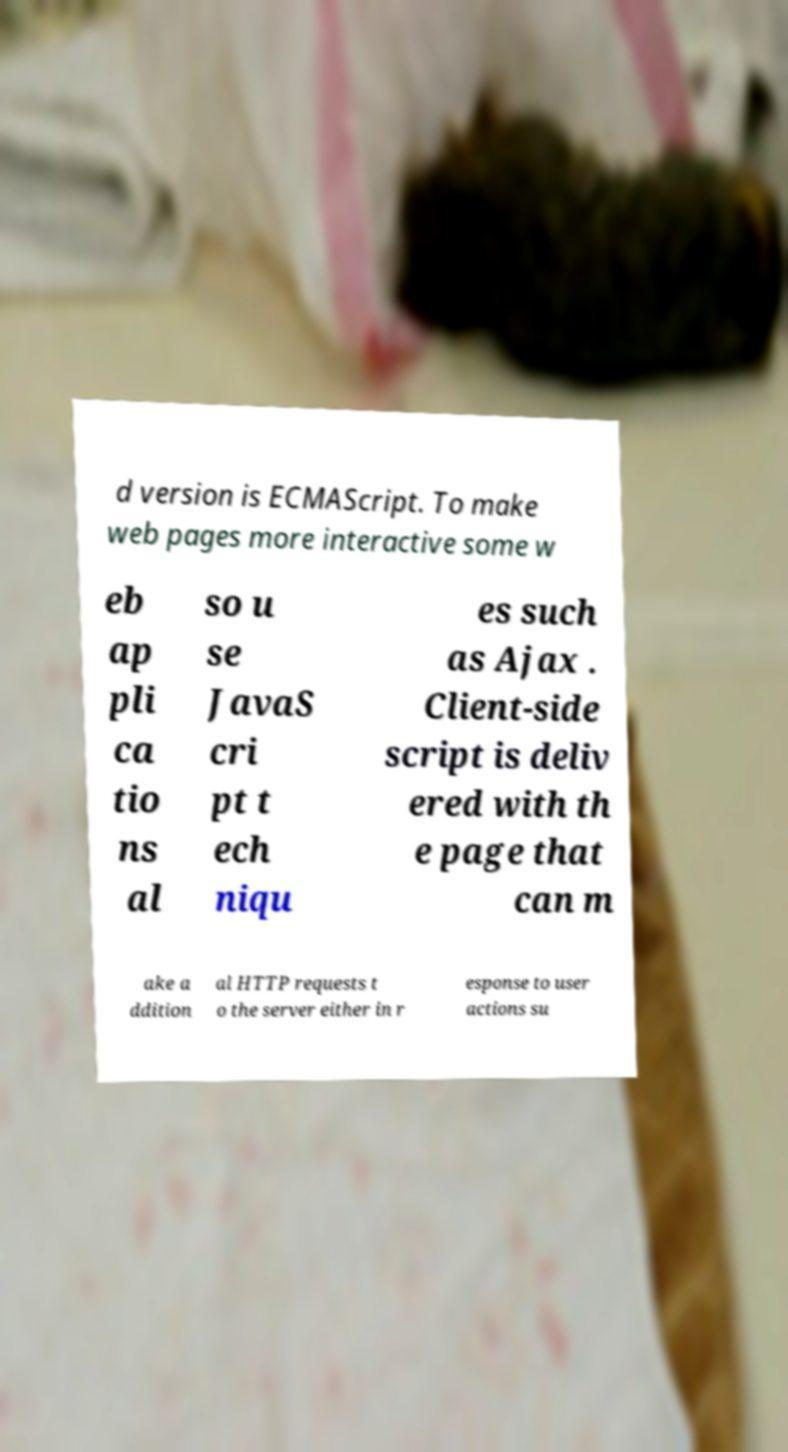I need the written content from this picture converted into text. Can you do that? d version is ECMAScript. To make web pages more interactive some w eb ap pli ca tio ns al so u se JavaS cri pt t ech niqu es such as Ajax . Client-side script is deliv ered with th e page that can m ake a ddition al HTTP requests t o the server either in r esponse to user actions su 